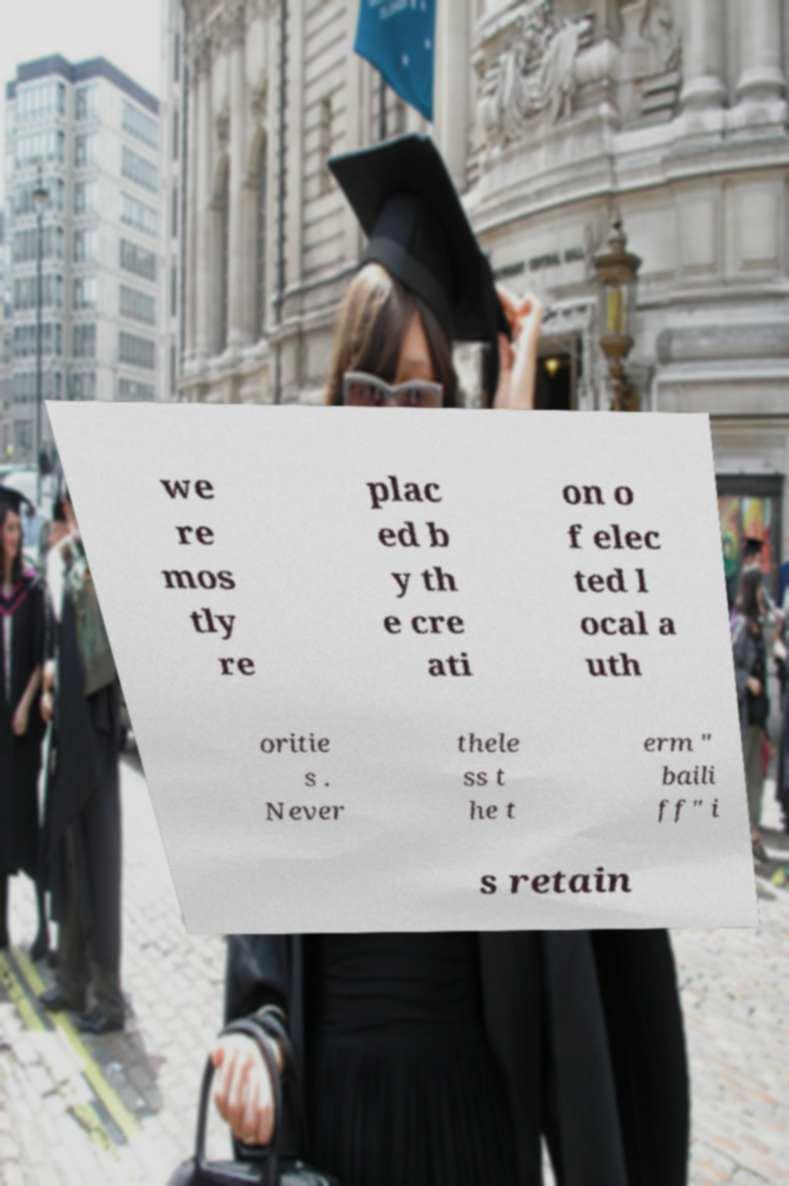For documentation purposes, I need the text within this image transcribed. Could you provide that? we re mos tly re plac ed b y th e cre ati on o f elec ted l ocal a uth oritie s . Never thele ss t he t erm " baili ff" i s retain 